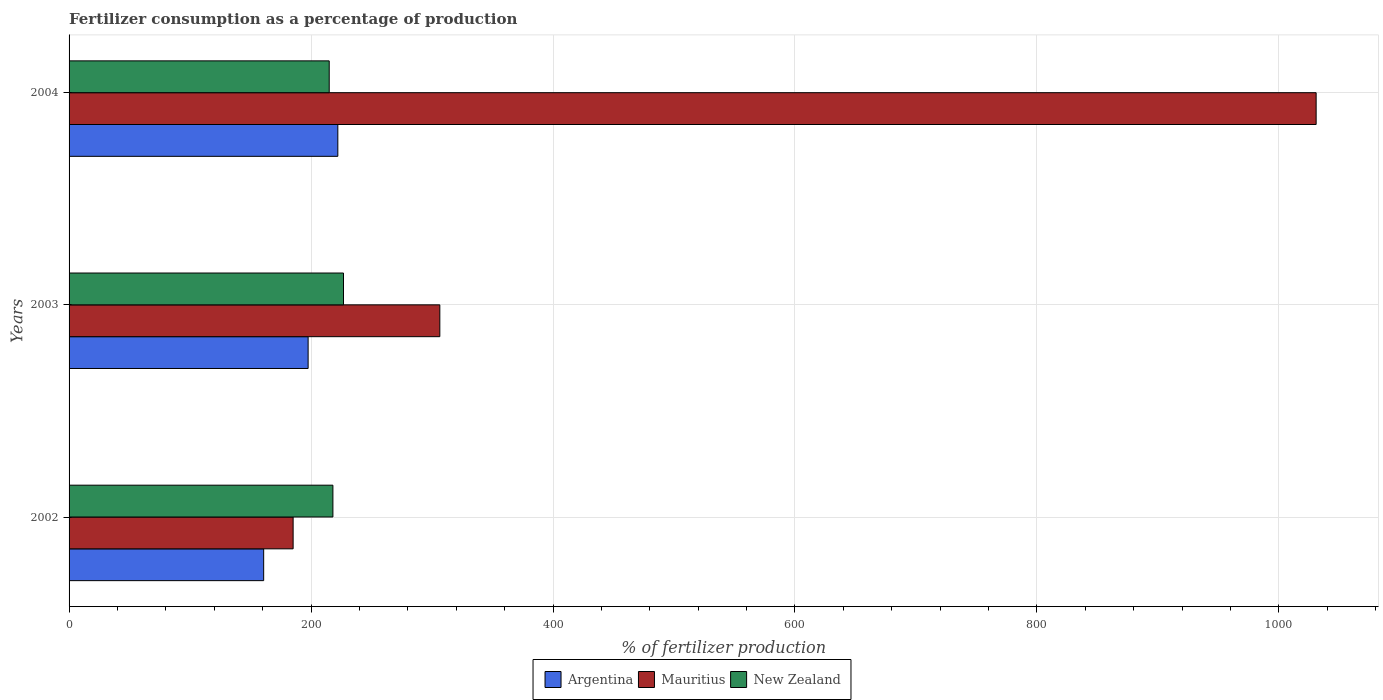How many different coloured bars are there?
Provide a succinct answer. 3. How many groups of bars are there?
Your answer should be very brief. 3. Are the number of bars on each tick of the Y-axis equal?
Your response must be concise. Yes. How many bars are there on the 2nd tick from the top?
Offer a very short reply. 3. How many bars are there on the 3rd tick from the bottom?
Ensure brevity in your answer.  3. In how many cases, is the number of bars for a given year not equal to the number of legend labels?
Offer a terse response. 0. What is the percentage of fertilizers consumed in New Zealand in 2003?
Keep it short and to the point. 226.83. Across all years, what is the maximum percentage of fertilizers consumed in Argentina?
Offer a very short reply. 222.14. Across all years, what is the minimum percentage of fertilizers consumed in Mauritius?
Ensure brevity in your answer.  185.2. In which year was the percentage of fertilizers consumed in Argentina maximum?
Your answer should be compact. 2004. In which year was the percentage of fertilizers consumed in New Zealand minimum?
Keep it short and to the point. 2004. What is the total percentage of fertilizers consumed in New Zealand in the graph?
Provide a short and direct response. 659.93. What is the difference between the percentage of fertilizers consumed in New Zealand in 2002 and that in 2004?
Make the answer very short. 3.05. What is the difference between the percentage of fertilizers consumed in Argentina in 2003 and the percentage of fertilizers consumed in Mauritius in 2002?
Your answer should be compact. 12.39. What is the average percentage of fertilizers consumed in New Zealand per year?
Ensure brevity in your answer.  219.98. In the year 2003, what is the difference between the percentage of fertilizers consumed in Argentina and percentage of fertilizers consumed in New Zealand?
Your answer should be compact. -29.25. What is the ratio of the percentage of fertilizers consumed in New Zealand in 2003 to that in 2004?
Your answer should be compact. 1.05. Is the difference between the percentage of fertilizers consumed in Argentina in 2002 and 2003 greater than the difference between the percentage of fertilizers consumed in New Zealand in 2002 and 2003?
Give a very brief answer. No. What is the difference between the highest and the second highest percentage of fertilizers consumed in Mauritius?
Keep it short and to the point. 724.31. What is the difference between the highest and the lowest percentage of fertilizers consumed in New Zealand?
Your response must be concise. 11.81. In how many years, is the percentage of fertilizers consumed in New Zealand greater than the average percentage of fertilizers consumed in New Zealand taken over all years?
Keep it short and to the point. 1. What does the 2nd bar from the top in 2002 represents?
Your answer should be very brief. Mauritius. What does the 1st bar from the bottom in 2003 represents?
Provide a succinct answer. Argentina. Is it the case that in every year, the sum of the percentage of fertilizers consumed in New Zealand and percentage of fertilizers consumed in Mauritius is greater than the percentage of fertilizers consumed in Argentina?
Offer a very short reply. Yes. How many bars are there?
Give a very brief answer. 9. Are all the bars in the graph horizontal?
Provide a short and direct response. Yes. Are the values on the major ticks of X-axis written in scientific E-notation?
Your answer should be compact. No. Does the graph contain grids?
Offer a very short reply. Yes. Where does the legend appear in the graph?
Your answer should be very brief. Bottom center. How many legend labels are there?
Provide a short and direct response. 3. How are the legend labels stacked?
Ensure brevity in your answer.  Horizontal. What is the title of the graph?
Your answer should be very brief. Fertilizer consumption as a percentage of production. Does "Nepal" appear as one of the legend labels in the graph?
Make the answer very short. No. What is the label or title of the X-axis?
Provide a succinct answer. % of fertilizer production. What is the % of fertilizer production in Argentina in 2002?
Provide a short and direct response. 160.85. What is the % of fertilizer production in Mauritius in 2002?
Your answer should be compact. 185.2. What is the % of fertilizer production in New Zealand in 2002?
Provide a short and direct response. 218.08. What is the % of fertilizer production of Argentina in 2003?
Provide a succinct answer. 197.58. What is the % of fertilizer production in Mauritius in 2003?
Ensure brevity in your answer.  306.45. What is the % of fertilizer production of New Zealand in 2003?
Your answer should be compact. 226.83. What is the % of fertilizer production in Argentina in 2004?
Your answer should be compact. 222.14. What is the % of fertilizer production of Mauritius in 2004?
Provide a short and direct response. 1030.77. What is the % of fertilizer production of New Zealand in 2004?
Offer a very short reply. 215.02. Across all years, what is the maximum % of fertilizer production of Argentina?
Ensure brevity in your answer.  222.14. Across all years, what is the maximum % of fertilizer production of Mauritius?
Make the answer very short. 1030.77. Across all years, what is the maximum % of fertilizer production in New Zealand?
Provide a short and direct response. 226.83. Across all years, what is the minimum % of fertilizer production of Argentina?
Provide a succinct answer. 160.85. Across all years, what is the minimum % of fertilizer production in Mauritius?
Your answer should be compact. 185.2. Across all years, what is the minimum % of fertilizer production of New Zealand?
Give a very brief answer. 215.02. What is the total % of fertilizer production of Argentina in the graph?
Ensure brevity in your answer.  580.58. What is the total % of fertilizer production in Mauritius in the graph?
Offer a terse response. 1522.42. What is the total % of fertilizer production in New Zealand in the graph?
Offer a very short reply. 659.93. What is the difference between the % of fertilizer production of Argentina in 2002 and that in 2003?
Offer a terse response. -36.73. What is the difference between the % of fertilizer production of Mauritius in 2002 and that in 2003?
Your answer should be very brief. -121.26. What is the difference between the % of fertilizer production of New Zealand in 2002 and that in 2003?
Provide a short and direct response. -8.76. What is the difference between the % of fertilizer production of Argentina in 2002 and that in 2004?
Provide a short and direct response. -61.29. What is the difference between the % of fertilizer production of Mauritius in 2002 and that in 2004?
Provide a succinct answer. -845.57. What is the difference between the % of fertilizer production of New Zealand in 2002 and that in 2004?
Offer a terse response. 3.05. What is the difference between the % of fertilizer production of Argentina in 2003 and that in 2004?
Offer a very short reply. -24.56. What is the difference between the % of fertilizer production in Mauritius in 2003 and that in 2004?
Your answer should be compact. -724.31. What is the difference between the % of fertilizer production of New Zealand in 2003 and that in 2004?
Make the answer very short. 11.81. What is the difference between the % of fertilizer production of Argentina in 2002 and the % of fertilizer production of Mauritius in 2003?
Offer a terse response. -145.6. What is the difference between the % of fertilizer production in Argentina in 2002 and the % of fertilizer production in New Zealand in 2003?
Give a very brief answer. -65.98. What is the difference between the % of fertilizer production in Mauritius in 2002 and the % of fertilizer production in New Zealand in 2003?
Ensure brevity in your answer.  -41.64. What is the difference between the % of fertilizer production of Argentina in 2002 and the % of fertilizer production of Mauritius in 2004?
Provide a short and direct response. -869.91. What is the difference between the % of fertilizer production of Argentina in 2002 and the % of fertilizer production of New Zealand in 2004?
Provide a short and direct response. -54.17. What is the difference between the % of fertilizer production in Mauritius in 2002 and the % of fertilizer production in New Zealand in 2004?
Give a very brief answer. -29.82. What is the difference between the % of fertilizer production in Argentina in 2003 and the % of fertilizer production in Mauritius in 2004?
Your answer should be compact. -833.18. What is the difference between the % of fertilizer production of Argentina in 2003 and the % of fertilizer production of New Zealand in 2004?
Offer a very short reply. -17.44. What is the difference between the % of fertilizer production in Mauritius in 2003 and the % of fertilizer production in New Zealand in 2004?
Make the answer very short. 91.43. What is the average % of fertilizer production in Argentina per year?
Keep it short and to the point. 193.53. What is the average % of fertilizer production of Mauritius per year?
Ensure brevity in your answer.  507.47. What is the average % of fertilizer production of New Zealand per year?
Make the answer very short. 219.98. In the year 2002, what is the difference between the % of fertilizer production of Argentina and % of fertilizer production of Mauritius?
Offer a very short reply. -24.34. In the year 2002, what is the difference between the % of fertilizer production in Argentina and % of fertilizer production in New Zealand?
Your answer should be compact. -57.22. In the year 2002, what is the difference between the % of fertilizer production of Mauritius and % of fertilizer production of New Zealand?
Keep it short and to the point. -32.88. In the year 2003, what is the difference between the % of fertilizer production of Argentina and % of fertilizer production of Mauritius?
Your answer should be very brief. -108.87. In the year 2003, what is the difference between the % of fertilizer production of Argentina and % of fertilizer production of New Zealand?
Keep it short and to the point. -29.25. In the year 2003, what is the difference between the % of fertilizer production in Mauritius and % of fertilizer production in New Zealand?
Provide a short and direct response. 79.62. In the year 2004, what is the difference between the % of fertilizer production of Argentina and % of fertilizer production of Mauritius?
Provide a short and direct response. -808.62. In the year 2004, what is the difference between the % of fertilizer production in Argentina and % of fertilizer production in New Zealand?
Offer a very short reply. 7.12. In the year 2004, what is the difference between the % of fertilizer production of Mauritius and % of fertilizer production of New Zealand?
Your answer should be very brief. 815.75. What is the ratio of the % of fertilizer production in Argentina in 2002 to that in 2003?
Offer a terse response. 0.81. What is the ratio of the % of fertilizer production in Mauritius in 2002 to that in 2003?
Your response must be concise. 0.6. What is the ratio of the % of fertilizer production in New Zealand in 2002 to that in 2003?
Provide a succinct answer. 0.96. What is the ratio of the % of fertilizer production of Argentina in 2002 to that in 2004?
Provide a succinct answer. 0.72. What is the ratio of the % of fertilizer production in Mauritius in 2002 to that in 2004?
Keep it short and to the point. 0.18. What is the ratio of the % of fertilizer production of New Zealand in 2002 to that in 2004?
Your answer should be very brief. 1.01. What is the ratio of the % of fertilizer production of Argentina in 2003 to that in 2004?
Your response must be concise. 0.89. What is the ratio of the % of fertilizer production of Mauritius in 2003 to that in 2004?
Give a very brief answer. 0.3. What is the ratio of the % of fertilizer production in New Zealand in 2003 to that in 2004?
Provide a short and direct response. 1.05. What is the difference between the highest and the second highest % of fertilizer production in Argentina?
Make the answer very short. 24.56. What is the difference between the highest and the second highest % of fertilizer production in Mauritius?
Your answer should be very brief. 724.31. What is the difference between the highest and the second highest % of fertilizer production in New Zealand?
Provide a succinct answer. 8.76. What is the difference between the highest and the lowest % of fertilizer production of Argentina?
Ensure brevity in your answer.  61.29. What is the difference between the highest and the lowest % of fertilizer production in Mauritius?
Give a very brief answer. 845.57. What is the difference between the highest and the lowest % of fertilizer production of New Zealand?
Keep it short and to the point. 11.81. 